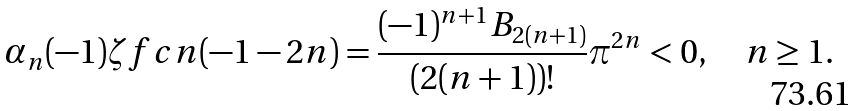<formula> <loc_0><loc_0><loc_500><loc_500>\alpha _ { n } ( - 1 ) \zeta f c n ( - 1 - 2 n ) = \frac { ( - 1 ) ^ { n + 1 } B _ { 2 ( n + 1 ) } } { ( 2 ( n + 1 ) ) ! } \pi ^ { 2 n } < 0 , \quad n \geq 1 .</formula> 